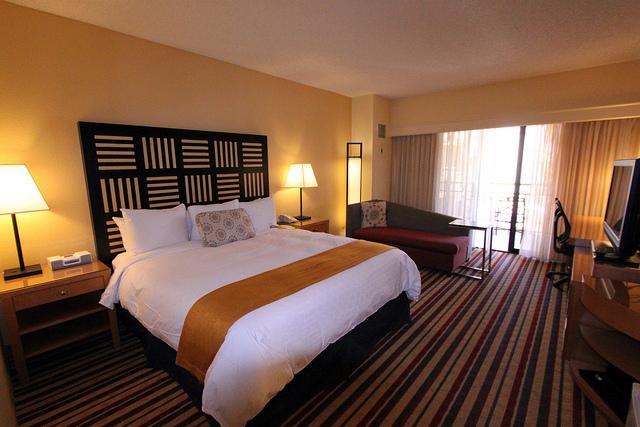Is there an ice bucket in the hotel room?
Give a very brief answer. No. How many pillows are on the bed?
Be succinct. 7. Where in there a big brown stripe?
Give a very brief answer. Bed. Is there a person in the room?
Write a very short answer. No. What color is the floor?
Answer briefly. Red, white and blue. How many lamps are on?
Quick response, please. 2. 